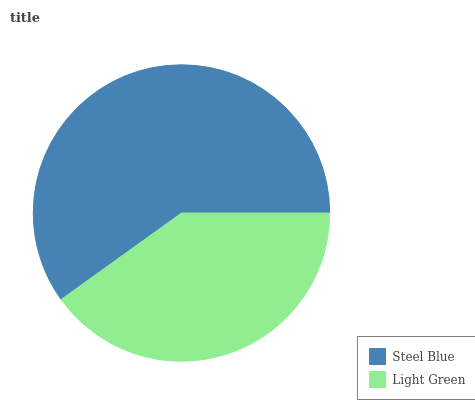Is Light Green the minimum?
Answer yes or no. Yes. Is Steel Blue the maximum?
Answer yes or no. Yes. Is Light Green the maximum?
Answer yes or no. No. Is Steel Blue greater than Light Green?
Answer yes or no. Yes. Is Light Green less than Steel Blue?
Answer yes or no. Yes. Is Light Green greater than Steel Blue?
Answer yes or no. No. Is Steel Blue less than Light Green?
Answer yes or no. No. Is Steel Blue the high median?
Answer yes or no. Yes. Is Light Green the low median?
Answer yes or no. Yes. Is Light Green the high median?
Answer yes or no. No. Is Steel Blue the low median?
Answer yes or no. No. 